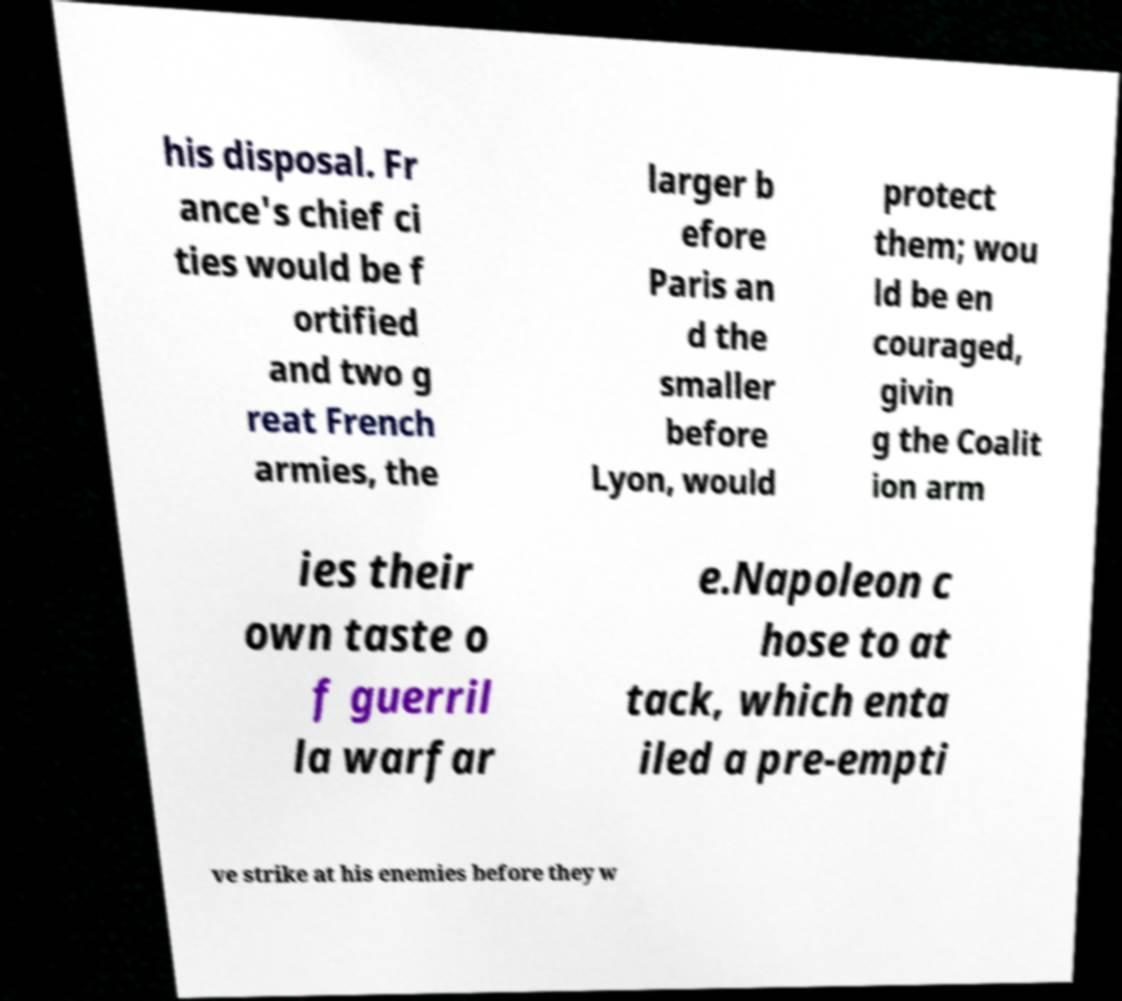Could you extract and type out the text from this image? his disposal. Fr ance's chief ci ties would be f ortified and two g reat French armies, the larger b efore Paris an d the smaller before Lyon, would protect them; wou ld be en couraged, givin g the Coalit ion arm ies their own taste o f guerril la warfar e.Napoleon c hose to at tack, which enta iled a pre-empti ve strike at his enemies before they w 